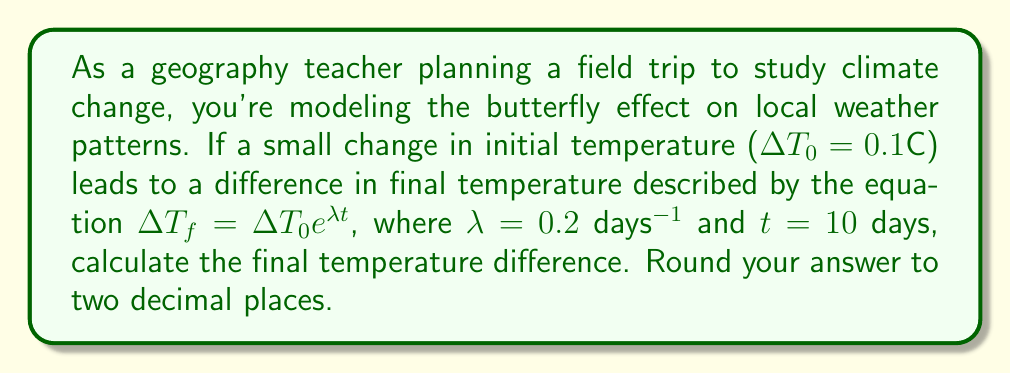Give your solution to this math problem. To solve this problem, we'll use the given equation and input the values:

1. Given equation: $\Delta T_f = \Delta T_0 e^{\lambda t}$
2. Known values:
   $\Delta T_0 = 0.1°C$
   $\lambda = 0.2$ days$^{-1}$
   $t = 10$ days

3. Substitute the values into the equation:
   $\Delta T_f = 0.1 \cdot e^{0.2 \cdot 10}$

4. Simplify the exponent:
   $\Delta T_f = 0.1 \cdot e^2$

5. Calculate $e^2$:
   $e^2 \approx 7.3890561$

6. Multiply:
   $\Delta T_f = 0.1 \cdot 7.3890561 = 0.73890561°C$

7. Round to two decimal places:
   $\Delta T_f \approx 0.74°C$

This result demonstrates how a small initial change can lead to a significantly larger effect over time, illustrating the butterfly effect in climate systems.
Answer: 0.74°C 